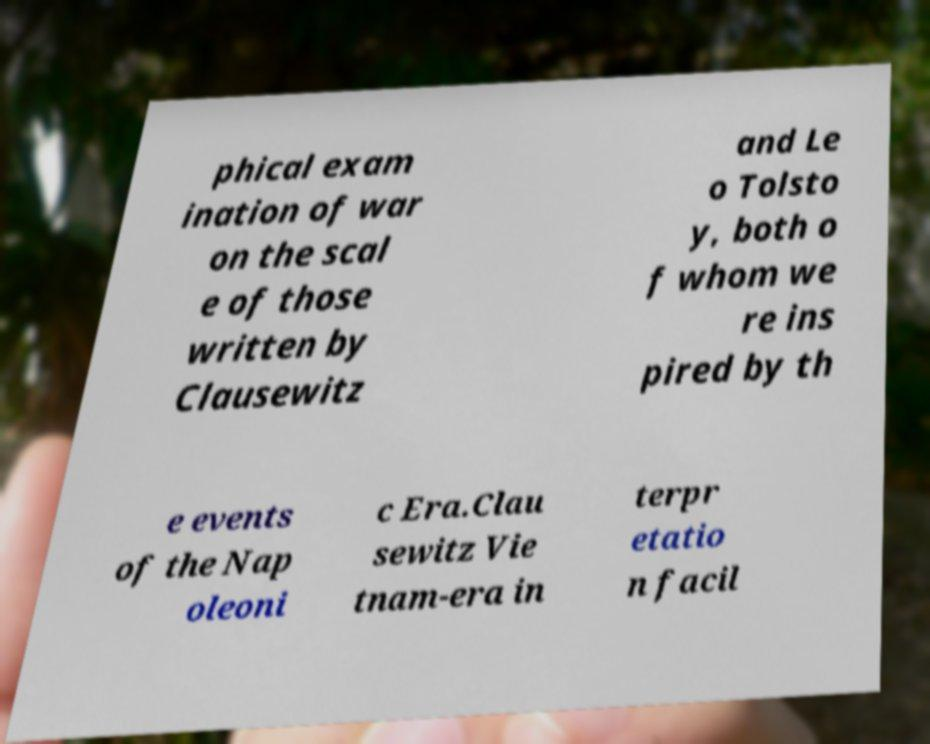What messages or text are displayed in this image? I need them in a readable, typed format. phical exam ination of war on the scal e of those written by Clausewitz and Le o Tolsto y, both o f whom we re ins pired by th e events of the Nap oleoni c Era.Clau sewitz Vie tnam-era in terpr etatio n facil 